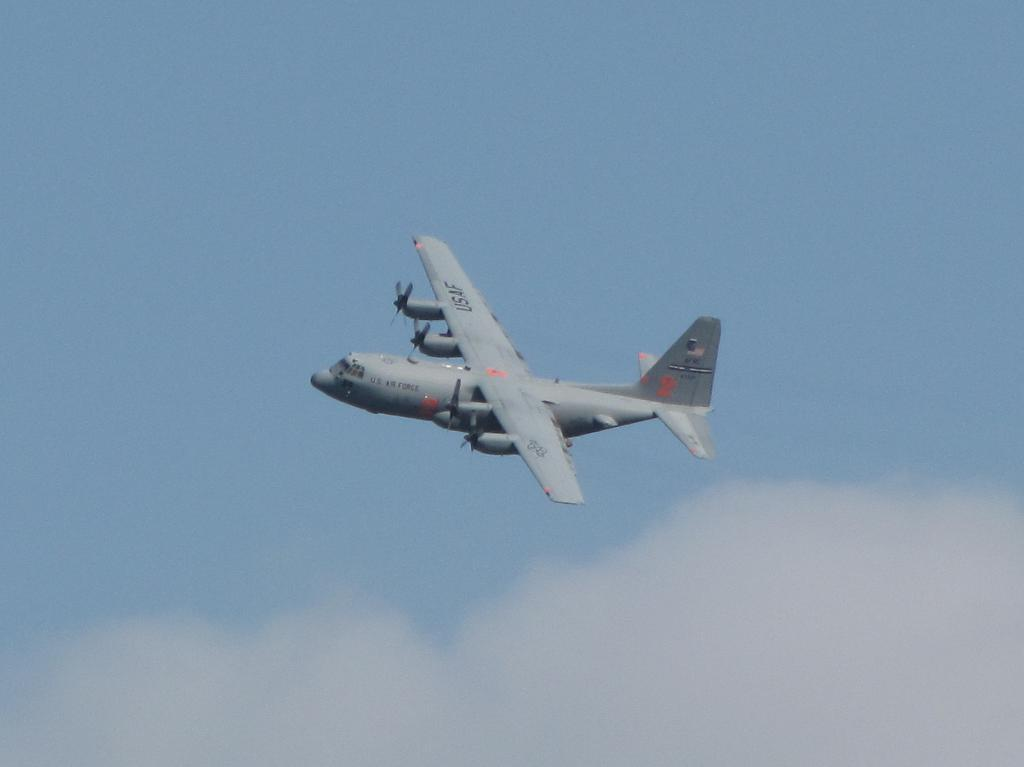What is happening in the image? There is a flight in the image. Where is the flight located? The flight is flying in the sky. What type of furniture can be seen inside the flight in the image? There is no furniture visible inside the flight in the image, as it is focused on the exterior of the aircraft. 